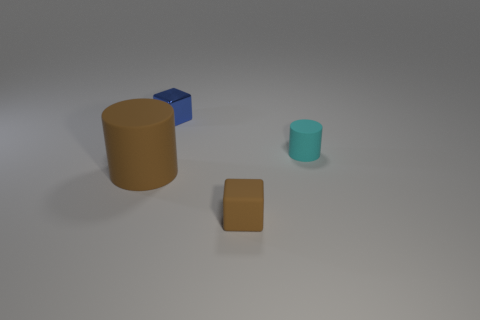Is there any other thing that is the same material as the tiny blue block?
Offer a very short reply. No. Is the small blue block made of the same material as the small cube to the right of the small blue cube?
Offer a terse response. No. Does the cylinder that is to the right of the small metal object have the same color as the matte block?
Ensure brevity in your answer.  No. What number of tiny cubes are in front of the small cylinder and on the left side of the small brown object?
Provide a succinct answer. 0. How many other things are made of the same material as the brown cylinder?
Provide a short and direct response. 2. Are the cylinder to the right of the blue thing and the small blue cube made of the same material?
Offer a very short reply. No. What is the size of the block behind the matte cylinder behind the cylinder to the left of the tiny brown object?
Provide a succinct answer. Small. How many other objects are the same color as the tiny matte cube?
Your response must be concise. 1. What is the shape of the brown matte object that is the same size as the metallic cube?
Provide a succinct answer. Cube. There is a thing that is behind the tiny matte cylinder; what is its size?
Ensure brevity in your answer.  Small. 